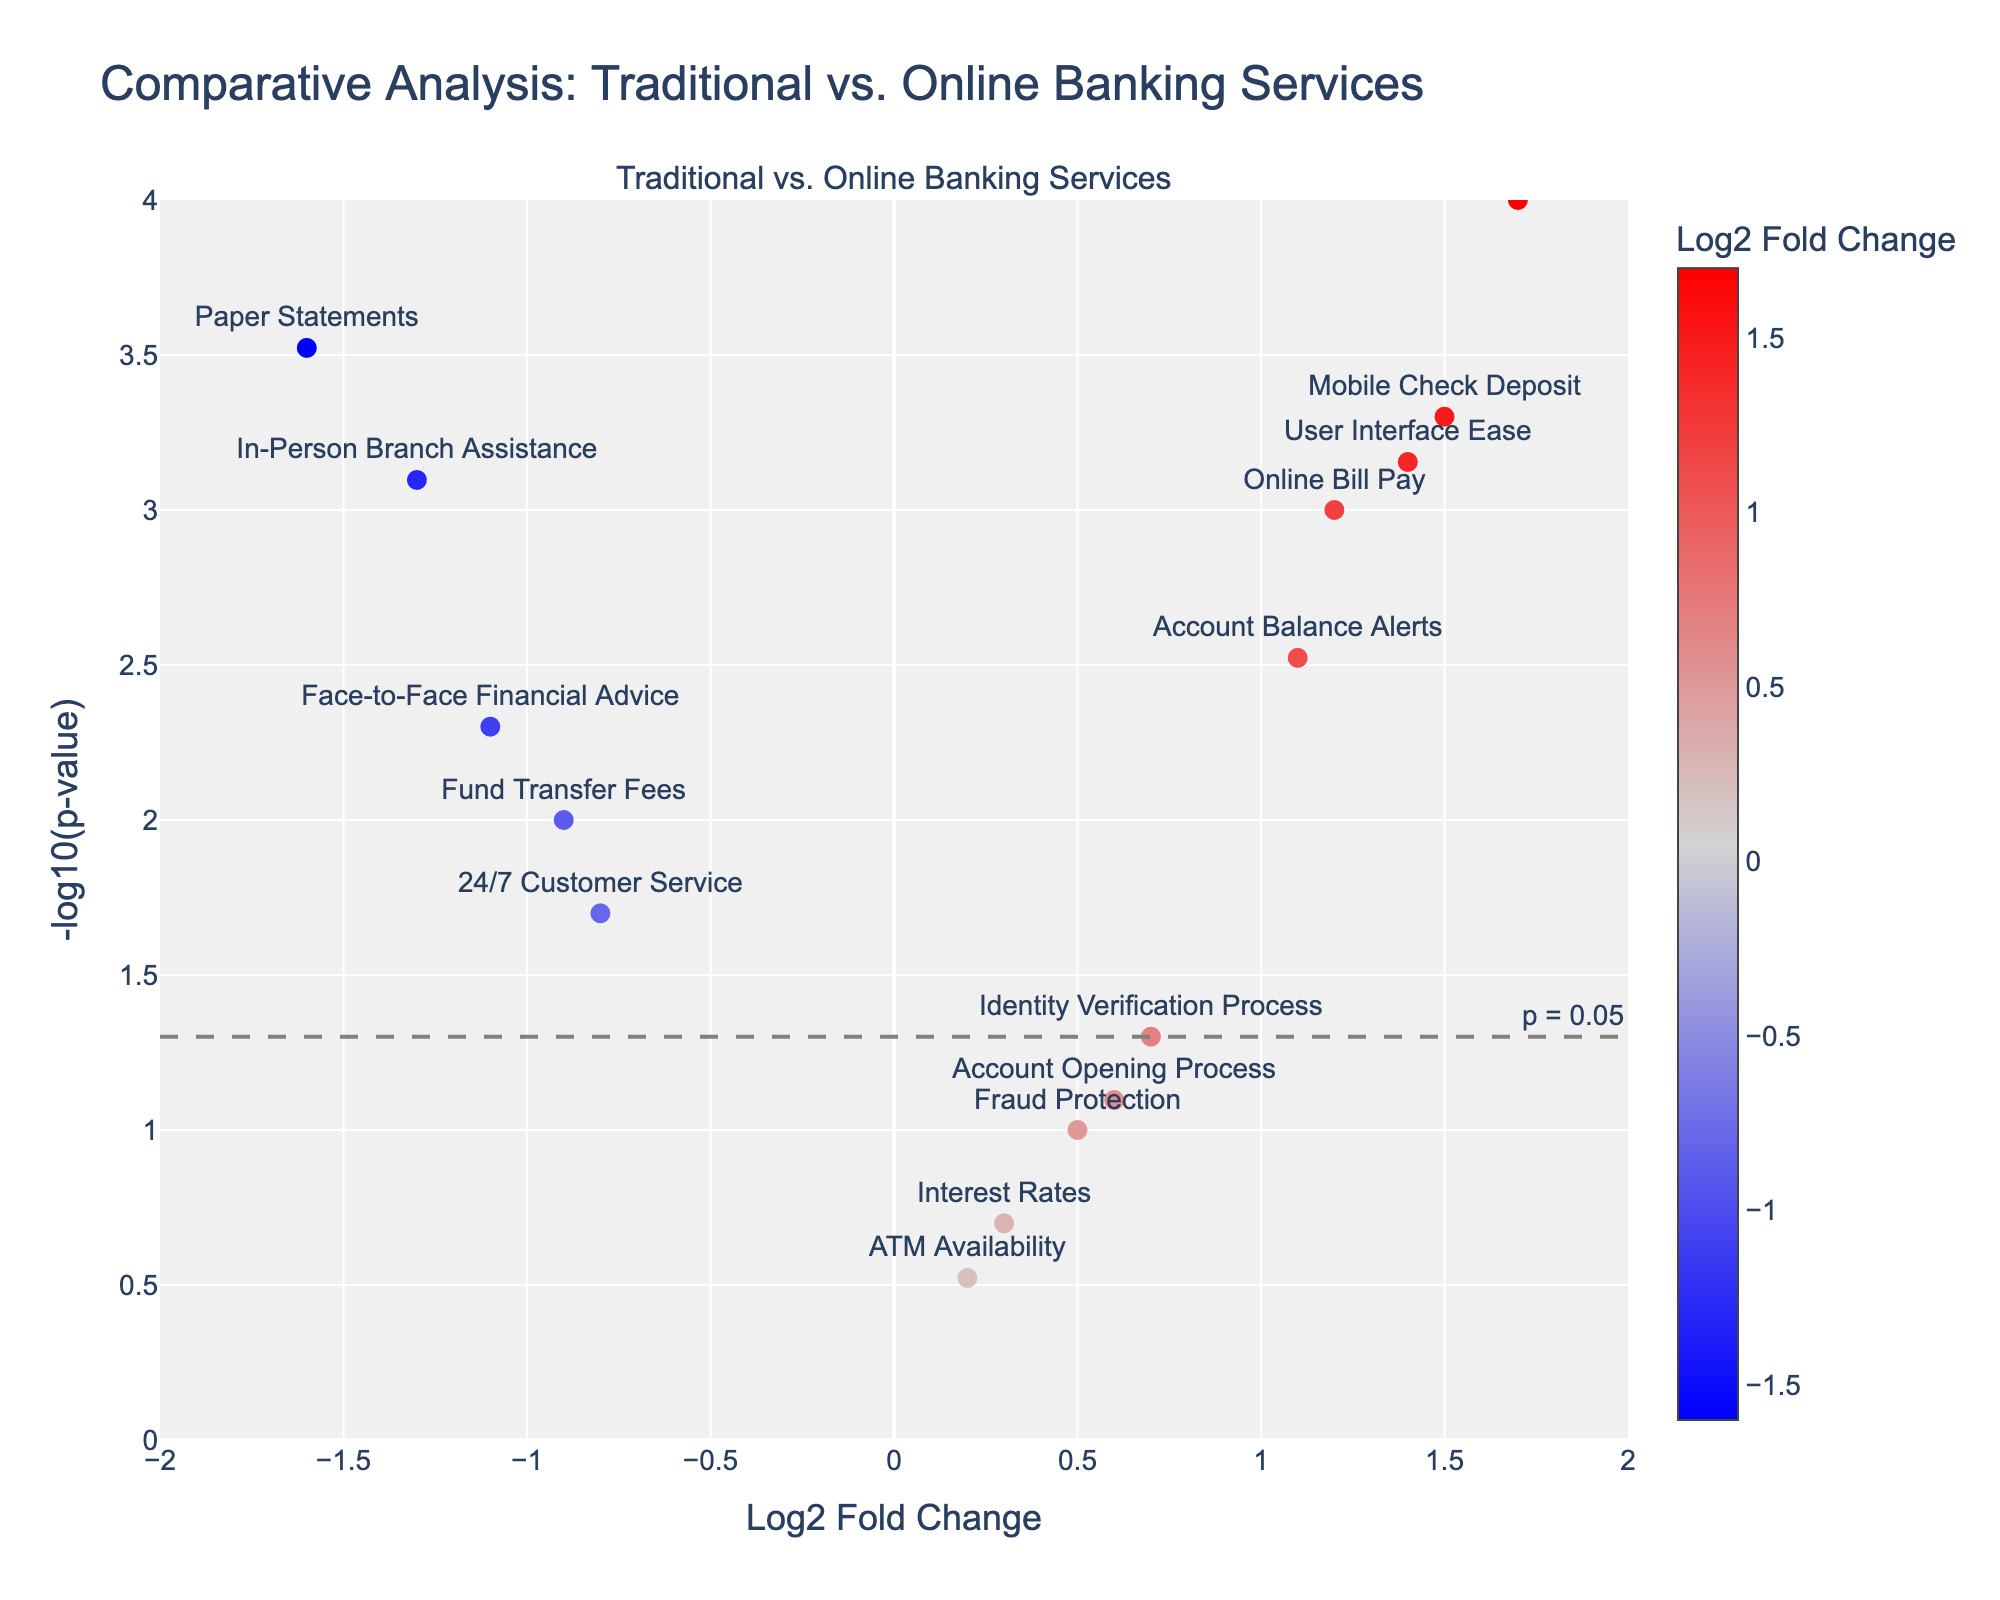What's the title of the plot? The title is displayed at the top of the plot. It reads, "Comparative Analysis: Traditional vs. Online Banking Services."
Answer: Comparative Analysis: Traditional vs. Online Banking Services What does a higher value on the y-axis indicate? The y-axis is labeled as "-log10(p-value)," meaning higher values indicate lower p-values, which suggests higher statistical significance.
Answer: Higher significance Which feature has the highest Log2 Fold Change? From the x-axis labeled "Log2 Fold Change," the point farthest to the right represents the highest Log2 Fold Change. Here, "Transaction Speed" is at approximately 1.7.
Answer: Transaction Speed Which features have p-values less than 0.05 and also have negative Log2 Fold Changes? The y-axis refers to significance, and the dashed line indicates the 0.05 threshold. Negative Log2 Fold Change values are on the left of the x-axis. "24/7 Customer Service," "In-Person Branch Assistance," "Paper Statements," and "Face-to-Face Financial Advice" fall into this category.
Answer: 24/7 Customer Service, In-Person Branch Assistance, Paper Statements, Face-to-Face Financial Advice Which feature is closest to the origin (Log2 Fold Change = 0, -log10(p-value) = 0)? The origin is where the x-axis and y-axis meet. The feature closest to (0,0) is "ATM Availability," with a Log2 Fold Change of around 0.2 and a higher p-value (lower y-value).
Answer: ATM Availability What does the color scale represent? The color scale is shown as a horizontal color bar, indicating Log2 Fold Change values, where positive values are red and negative values are blue.
Answer: Log2 Fold Change Which security-related feature shows a positive but not statistically significant change? Security-related features include "Fraud Protection" and "Identity Verification Process." "Identity Verification Process" has a p-value near 0.05 and a positive Log2 Fold Change, closer to zero. "Fraud Protection" has an even higher p-value around 0.1.
Answer: Fraud Protection How many features have positive Log2 Fold Changes and are statistically significant? Positive Log2 Fold Changes are right of the y-axis, and significance is above the dotted y-line. Features that meet both criteria include "Online Bill Pay," "Mobile Check Deposit," "Account Balance Alerts," "Transaction Speed," and "User Interface Ease."
Answer: 5 What is the Log2 Fold Change and p-value of "Face-to-Face Financial Advice"? The "Face-to-Face Financial Advice" point's coordinates are specified by its position. It is at a Log2 Fold Change of approximately -1.1 and a p-value transformed to -log10 = around 2.3. So, p-value ≈ 0.005.
Answer: Log2 Fold Change: -1.1, p-value: 0.005 What can be inferred about "Paper Statements" compared to "Account Balance Alerts"? "Paper Statements" has a highly negative Log2 Fold Change and significant p-value (leftmost point), indicating it is less favored. "Account Balance Alerts" has a positive Log2 Fold Change and is also significant (on the right). Therefore, "Account Balance Alerts" is more favored compared to "Paper Statements."
Answer: Account Balance Alerts more favored 